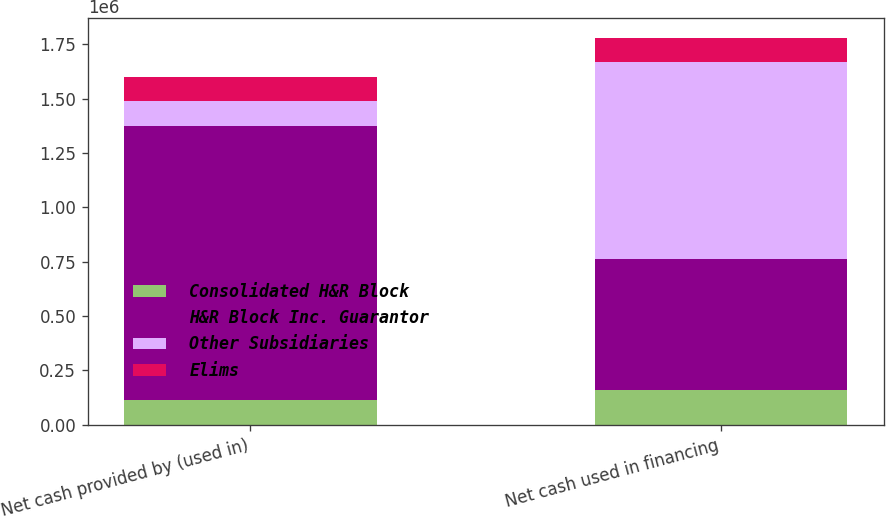<chart> <loc_0><loc_0><loc_500><loc_500><stacked_bar_chart><ecel><fcel>Net cash provided by (used in)<fcel>Net cash used in financing<nl><fcel>Consolidated H&R Block<fcel>112027<fcel>159548<nl><fcel>H&R Block Inc. Guarantor<fcel>1.26226e+06<fcel>601254<nl><fcel>Other Subsidiaries<fcel>114970<fcel>908647<nl><fcel>Elims<fcel>112027<fcel>111380<nl></chart> 